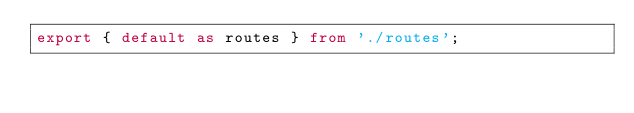Convert code to text. <code><loc_0><loc_0><loc_500><loc_500><_TypeScript_>export { default as routes } from './routes';</code> 